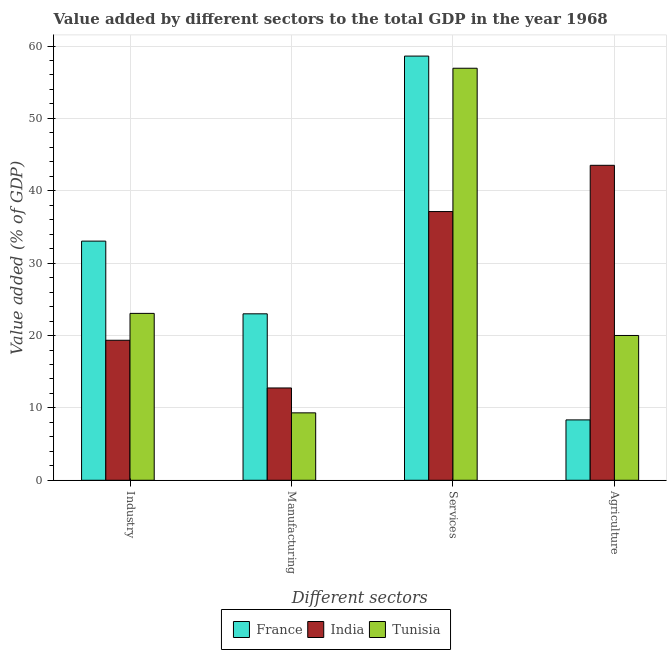How many different coloured bars are there?
Keep it short and to the point. 3. How many groups of bars are there?
Offer a very short reply. 4. Are the number of bars per tick equal to the number of legend labels?
Offer a terse response. Yes. Are the number of bars on each tick of the X-axis equal?
Provide a succinct answer. Yes. How many bars are there on the 4th tick from the left?
Provide a short and direct response. 3. What is the label of the 1st group of bars from the left?
Keep it short and to the point. Industry. What is the value added by services sector in Tunisia?
Provide a succinct answer. 56.93. Across all countries, what is the maximum value added by agricultural sector?
Provide a short and direct response. 43.52. Across all countries, what is the minimum value added by manufacturing sector?
Offer a terse response. 9.32. In which country was the value added by manufacturing sector maximum?
Your answer should be compact. France. What is the total value added by manufacturing sector in the graph?
Your answer should be compact. 45.07. What is the difference between the value added by industrial sector in India and that in Tunisia?
Your response must be concise. -3.71. What is the difference between the value added by manufacturing sector in Tunisia and the value added by services sector in France?
Ensure brevity in your answer.  -49.3. What is the average value added by services sector per country?
Keep it short and to the point. 50.89. What is the difference between the value added by industrial sector and value added by agricultural sector in India?
Make the answer very short. -24.17. What is the ratio of the value added by agricultural sector in France to that in India?
Make the answer very short. 0.19. What is the difference between the highest and the second highest value added by agricultural sector?
Offer a terse response. 23.51. What is the difference between the highest and the lowest value added by manufacturing sector?
Offer a terse response. 13.68. In how many countries, is the value added by manufacturing sector greater than the average value added by manufacturing sector taken over all countries?
Your response must be concise. 1. Is it the case that in every country, the sum of the value added by agricultural sector and value added by industrial sector is greater than the sum of value added by manufacturing sector and value added by services sector?
Make the answer very short. No. What does the 3rd bar from the left in Services represents?
Provide a succinct answer. Tunisia. Is it the case that in every country, the sum of the value added by industrial sector and value added by manufacturing sector is greater than the value added by services sector?
Offer a very short reply. No. How many bars are there?
Provide a succinct answer. 12. Are all the bars in the graph horizontal?
Provide a succinct answer. No. How many countries are there in the graph?
Make the answer very short. 3. What is the difference between two consecutive major ticks on the Y-axis?
Make the answer very short. 10. Are the values on the major ticks of Y-axis written in scientific E-notation?
Offer a very short reply. No. Does the graph contain grids?
Offer a very short reply. Yes. How many legend labels are there?
Keep it short and to the point. 3. What is the title of the graph?
Provide a short and direct response. Value added by different sectors to the total GDP in the year 1968. Does "Italy" appear as one of the legend labels in the graph?
Offer a terse response. No. What is the label or title of the X-axis?
Offer a terse response. Different sectors. What is the label or title of the Y-axis?
Ensure brevity in your answer.  Value added (% of GDP). What is the Value added (% of GDP) of France in Industry?
Your answer should be compact. 33.04. What is the Value added (% of GDP) of India in Industry?
Make the answer very short. 19.35. What is the Value added (% of GDP) of Tunisia in Industry?
Keep it short and to the point. 23.06. What is the Value added (% of GDP) in France in Manufacturing?
Offer a very short reply. 23. What is the Value added (% of GDP) of India in Manufacturing?
Provide a succinct answer. 12.75. What is the Value added (% of GDP) of Tunisia in Manufacturing?
Your answer should be very brief. 9.32. What is the Value added (% of GDP) in France in Services?
Your response must be concise. 58.61. What is the Value added (% of GDP) of India in Services?
Your answer should be very brief. 37.13. What is the Value added (% of GDP) of Tunisia in Services?
Provide a short and direct response. 56.93. What is the Value added (% of GDP) of France in Agriculture?
Your answer should be compact. 8.34. What is the Value added (% of GDP) of India in Agriculture?
Ensure brevity in your answer.  43.52. What is the Value added (% of GDP) of Tunisia in Agriculture?
Offer a terse response. 20.01. Across all Different sectors, what is the maximum Value added (% of GDP) of France?
Ensure brevity in your answer.  58.61. Across all Different sectors, what is the maximum Value added (% of GDP) in India?
Provide a succinct answer. 43.52. Across all Different sectors, what is the maximum Value added (% of GDP) in Tunisia?
Give a very brief answer. 56.93. Across all Different sectors, what is the minimum Value added (% of GDP) in France?
Your answer should be very brief. 8.34. Across all Different sectors, what is the minimum Value added (% of GDP) of India?
Provide a short and direct response. 12.75. Across all Different sectors, what is the minimum Value added (% of GDP) in Tunisia?
Provide a succinct answer. 9.32. What is the total Value added (% of GDP) of France in the graph?
Your answer should be very brief. 123. What is the total Value added (% of GDP) in India in the graph?
Offer a terse response. 112.75. What is the total Value added (% of GDP) in Tunisia in the graph?
Your response must be concise. 109.32. What is the difference between the Value added (% of GDP) in France in Industry and that in Manufacturing?
Keep it short and to the point. 10.04. What is the difference between the Value added (% of GDP) in India in Industry and that in Manufacturing?
Ensure brevity in your answer.  6.59. What is the difference between the Value added (% of GDP) of Tunisia in Industry and that in Manufacturing?
Provide a succinct answer. 13.74. What is the difference between the Value added (% of GDP) in France in Industry and that in Services?
Your answer should be very brief. -25.57. What is the difference between the Value added (% of GDP) of India in Industry and that in Services?
Provide a succinct answer. -17.78. What is the difference between the Value added (% of GDP) of Tunisia in Industry and that in Services?
Provide a succinct answer. -33.87. What is the difference between the Value added (% of GDP) of France in Industry and that in Agriculture?
Offer a terse response. 24.7. What is the difference between the Value added (% of GDP) in India in Industry and that in Agriculture?
Keep it short and to the point. -24.17. What is the difference between the Value added (% of GDP) of Tunisia in Industry and that in Agriculture?
Offer a very short reply. 3.05. What is the difference between the Value added (% of GDP) of France in Manufacturing and that in Services?
Provide a short and direct response. -35.61. What is the difference between the Value added (% of GDP) of India in Manufacturing and that in Services?
Offer a very short reply. -24.38. What is the difference between the Value added (% of GDP) of Tunisia in Manufacturing and that in Services?
Offer a very short reply. -47.62. What is the difference between the Value added (% of GDP) in France in Manufacturing and that in Agriculture?
Your answer should be compact. 14.66. What is the difference between the Value added (% of GDP) of India in Manufacturing and that in Agriculture?
Offer a terse response. -30.77. What is the difference between the Value added (% of GDP) in Tunisia in Manufacturing and that in Agriculture?
Provide a short and direct response. -10.69. What is the difference between the Value added (% of GDP) in France in Services and that in Agriculture?
Your answer should be very brief. 50.27. What is the difference between the Value added (% of GDP) in India in Services and that in Agriculture?
Offer a very short reply. -6.39. What is the difference between the Value added (% of GDP) in Tunisia in Services and that in Agriculture?
Ensure brevity in your answer.  36.93. What is the difference between the Value added (% of GDP) in France in Industry and the Value added (% of GDP) in India in Manufacturing?
Provide a short and direct response. 20.29. What is the difference between the Value added (% of GDP) in France in Industry and the Value added (% of GDP) in Tunisia in Manufacturing?
Make the answer very short. 23.73. What is the difference between the Value added (% of GDP) in India in Industry and the Value added (% of GDP) in Tunisia in Manufacturing?
Give a very brief answer. 10.03. What is the difference between the Value added (% of GDP) in France in Industry and the Value added (% of GDP) in India in Services?
Give a very brief answer. -4.09. What is the difference between the Value added (% of GDP) of France in Industry and the Value added (% of GDP) of Tunisia in Services?
Give a very brief answer. -23.89. What is the difference between the Value added (% of GDP) in India in Industry and the Value added (% of GDP) in Tunisia in Services?
Offer a terse response. -37.59. What is the difference between the Value added (% of GDP) in France in Industry and the Value added (% of GDP) in India in Agriculture?
Provide a succinct answer. -10.48. What is the difference between the Value added (% of GDP) of France in Industry and the Value added (% of GDP) of Tunisia in Agriculture?
Offer a very short reply. 13.04. What is the difference between the Value added (% of GDP) in India in Industry and the Value added (% of GDP) in Tunisia in Agriculture?
Offer a terse response. -0.66. What is the difference between the Value added (% of GDP) of France in Manufacturing and the Value added (% of GDP) of India in Services?
Offer a very short reply. -14.13. What is the difference between the Value added (% of GDP) of France in Manufacturing and the Value added (% of GDP) of Tunisia in Services?
Your answer should be very brief. -33.93. What is the difference between the Value added (% of GDP) of India in Manufacturing and the Value added (% of GDP) of Tunisia in Services?
Your response must be concise. -44.18. What is the difference between the Value added (% of GDP) in France in Manufacturing and the Value added (% of GDP) in India in Agriculture?
Ensure brevity in your answer.  -20.52. What is the difference between the Value added (% of GDP) of France in Manufacturing and the Value added (% of GDP) of Tunisia in Agriculture?
Give a very brief answer. 2.99. What is the difference between the Value added (% of GDP) in India in Manufacturing and the Value added (% of GDP) in Tunisia in Agriculture?
Your response must be concise. -7.25. What is the difference between the Value added (% of GDP) of France in Services and the Value added (% of GDP) of India in Agriculture?
Offer a very short reply. 15.09. What is the difference between the Value added (% of GDP) in France in Services and the Value added (% of GDP) in Tunisia in Agriculture?
Your answer should be compact. 38.61. What is the difference between the Value added (% of GDP) in India in Services and the Value added (% of GDP) in Tunisia in Agriculture?
Your answer should be compact. 17.12. What is the average Value added (% of GDP) of France per Different sectors?
Give a very brief answer. 30.75. What is the average Value added (% of GDP) of India per Different sectors?
Your answer should be compact. 28.19. What is the average Value added (% of GDP) of Tunisia per Different sectors?
Ensure brevity in your answer.  27.33. What is the difference between the Value added (% of GDP) in France and Value added (% of GDP) in India in Industry?
Your response must be concise. 13.7. What is the difference between the Value added (% of GDP) in France and Value added (% of GDP) in Tunisia in Industry?
Provide a succinct answer. 9.99. What is the difference between the Value added (% of GDP) in India and Value added (% of GDP) in Tunisia in Industry?
Ensure brevity in your answer.  -3.71. What is the difference between the Value added (% of GDP) in France and Value added (% of GDP) in India in Manufacturing?
Provide a short and direct response. 10.25. What is the difference between the Value added (% of GDP) of France and Value added (% of GDP) of Tunisia in Manufacturing?
Make the answer very short. 13.68. What is the difference between the Value added (% of GDP) of India and Value added (% of GDP) of Tunisia in Manufacturing?
Your response must be concise. 3.44. What is the difference between the Value added (% of GDP) of France and Value added (% of GDP) of India in Services?
Provide a short and direct response. 21.48. What is the difference between the Value added (% of GDP) of France and Value added (% of GDP) of Tunisia in Services?
Your answer should be compact. 1.68. What is the difference between the Value added (% of GDP) of India and Value added (% of GDP) of Tunisia in Services?
Give a very brief answer. -19.8. What is the difference between the Value added (% of GDP) of France and Value added (% of GDP) of India in Agriculture?
Provide a short and direct response. -35.18. What is the difference between the Value added (% of GDP) of France and Value added (% of GDP) of Tunisia in Agriculture?
Offer a very short reply. -11.66. What is the difference between the Value added (% of GDP) in India and Value added (% of GDP) in Tunisia in Agriculture?
Offer a terse response. 23.51. What is the ratio of the Value added (% of GDP) in France in Industry to that in Manufacturing?
Keep it short and to the point. 1.44. What is the ratio of the Value added (% of GDP) in India in Industry to that in Manufacturing?
Provide a short and direct response. 1.52. What is the ratio of the Value added (% of GDP) in Tunisia in Industry to that in Manufacturing?
Your answer should be compact. 2.48. What is the ratio of the Value added (% of GDP) in France in Industry to that in Services?
Your answer should be compact. 0.56. What is the ratio of the Value added (% of GDP) in India in Industry to that in Services?
Give a very brief answer. 0.52. What is the ratio of the Value added (% of GDP) of Tunisia in Industry to that in Services?
Provide a short and direct response. 0.41. What is the ratio of the Value added (% of GDP) in France in Industry to that in Agriculture?
Keep it short and to the point. 3.96. What is the ratio of the Value added (% of GDP) in India in Industry to that in Agriculture?
Make the answer very short. 0.44. What is the ratio of the Value added (% of GDP) of Tunisia in Industry to that in Agriculture?
Provide a short and direct response. 1.15. What is the ratio of the Value added (% of GDP) of France in Manufacturing to that in Services?
Provide a succinct answer. 0.39. What is the ratio of the Value added (% of GDP) of India in Manufacturing to that in Services?
Offer a very short reply. 0.34. What is the ratio of the Value added (% of GDP) of Tunisia in Manufacturing to that in Services?
Offer a terse response. 0.16. What is the ratio of the Value added (% of GDP) of France in Manufacturing to that in Agriculture?
Your answer should be very brief. 2.76. What is the ratio of the Value added (% of GDP) in India in Manufacturing to that in Agriculture?
Offer a terse response. 0.29. What is the ratio of the Value added (% of GDP) of Tunisia in Manufacturing to that in Agriculture?
Keep it short and to the point. 0.47. What is the ratio of the Value added (% of GDP) in France in Services to that in Agriculture?
Ensure brevity in your answer.  7.03. What is the ratio of the Value added (% of GDP) in India in Services to that in Agriculture?
Offer a terse response. 0.85. What is the ratio of the Value added (% of GDP) in Tunisia in Services to that in Agriculture?
Offer a very short reply. 2.85. What is the difference between the highest and the second highest Value added (% of GDP) in France?
Provide a short and direct response. 25.57. What is the difference between the highest and the second highest Value added (% of GDP) of India?
Your response must be concise. 6.39. What is the difference between the highest and the second highest Value added (% of GDP) of Tunisia?
Keep it short and to the point. 33.87. What is the difference between the highest and the lowest Value added (% of GDP) of France?
Provide a succinct answer. 50.27. What is the difference between the highest and the lowest Value added (% of GDP) in India?
Provide a short and direct response. 30.77. What is the difference between the highest and the lowest Value added (% of GDP) in Tunisia?
Offer a terse response. 47.62. 